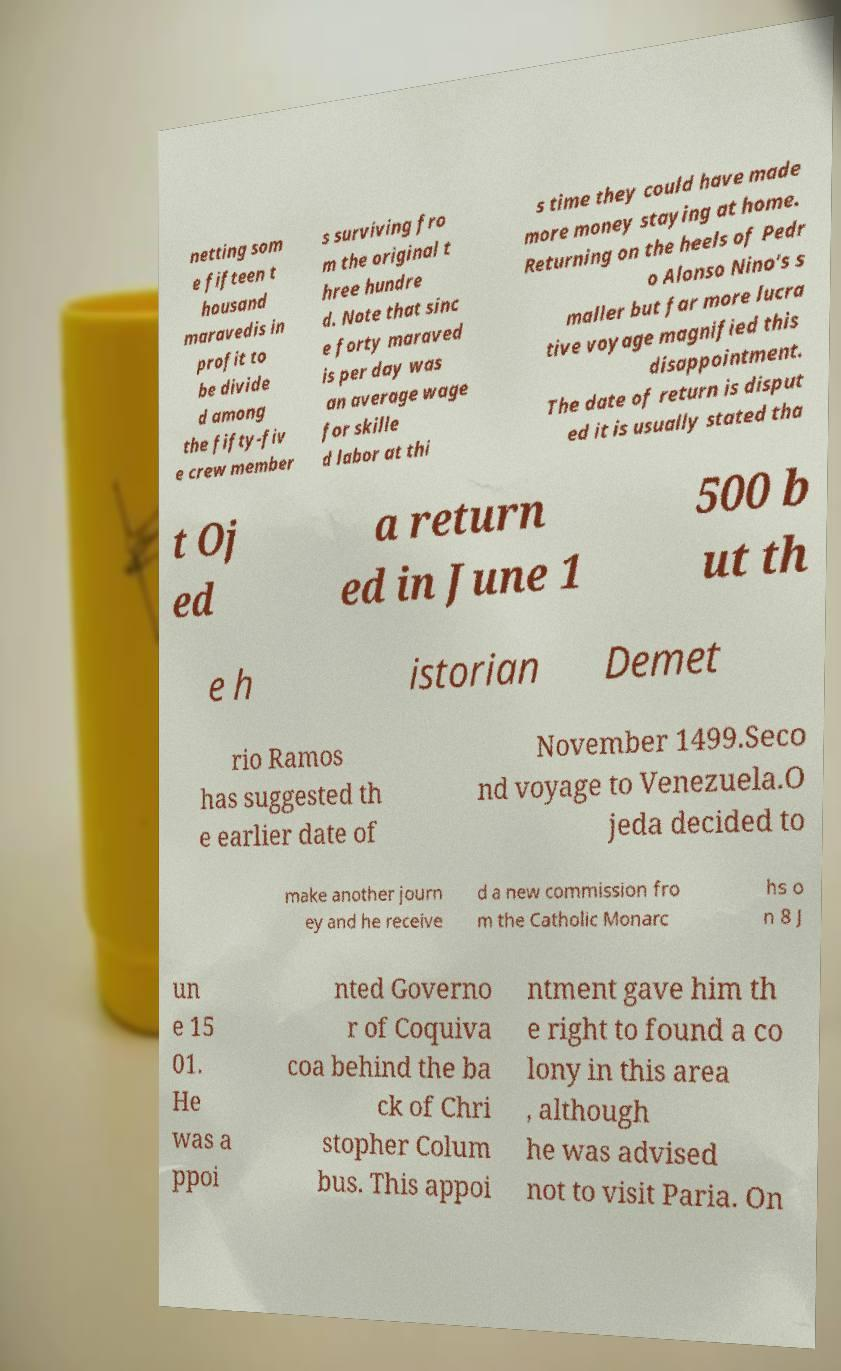There's text embedded in this image that I need extracted. Can you transcribe it verbatim? netting som e fifteen t housand maravedis in profit to be divide d among the fifty-fiv e crew member s surviving fro m the original t hree hundre d. Note that sinc e forty maraved is per day was an average wage for skille d labor at thi s time they could have made more money staying at home. Returning on the heels of Pedr o Alonso Nino's s maller but far more lucra tive voyage magnified this disappointment. The date of return is disput ed it is usually stated tha t Oj ed a return ed in June 1 500 b ut th e h istorian Demet rio Ramos has suggested th e earlier date of November 1499.Seco nd voyage to Venezuela.O jeda decided to make another journ ey and he receive d a new commission fro m the Catholic Monarc hs o n 8 J un e 15 01. He was a ppoi nted Governo r of Coquiva coa behind the ba ck of Chri stopher Colum bus. This appoi ntment gave him th e right to found a co lony in this area , although he was advised not to visit Paria. On 